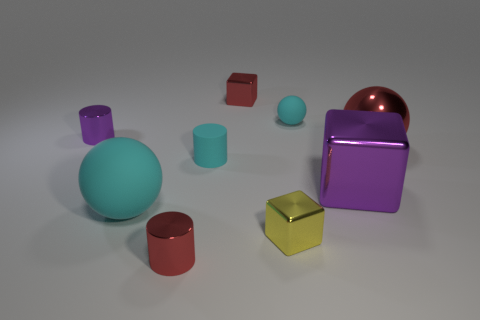Subtract all cylinders. How many objects are left? 6 Subtract all small cyan matte spheres. How many spheres are left? 2 Subtract 2 cubes. How many cubes are left? 1 Subtract all gray spheres. Subtract all green blocks. How many spheres are left? 3 Subtract all green spheres. How many yellow blocks are left? 1 Subtract all tiny yellow cubes. Subtract all small purple metallic things. How many objects are left? 7 Add 6 large cyan balls. How many large cyan balls are left? 7 Add 6 tiny shiny things. How many tiny shiny things exist? 10 Add 1 tiny yellow metallic blocks. How many objects exist? 10 Subtract all cyan balls. How many balls are left? 1 